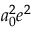<formula> <loc_0><loc_0><loc_500><loc_500>a _ { 0 } ^ { 2 } e ^ { 2 }</formula> 